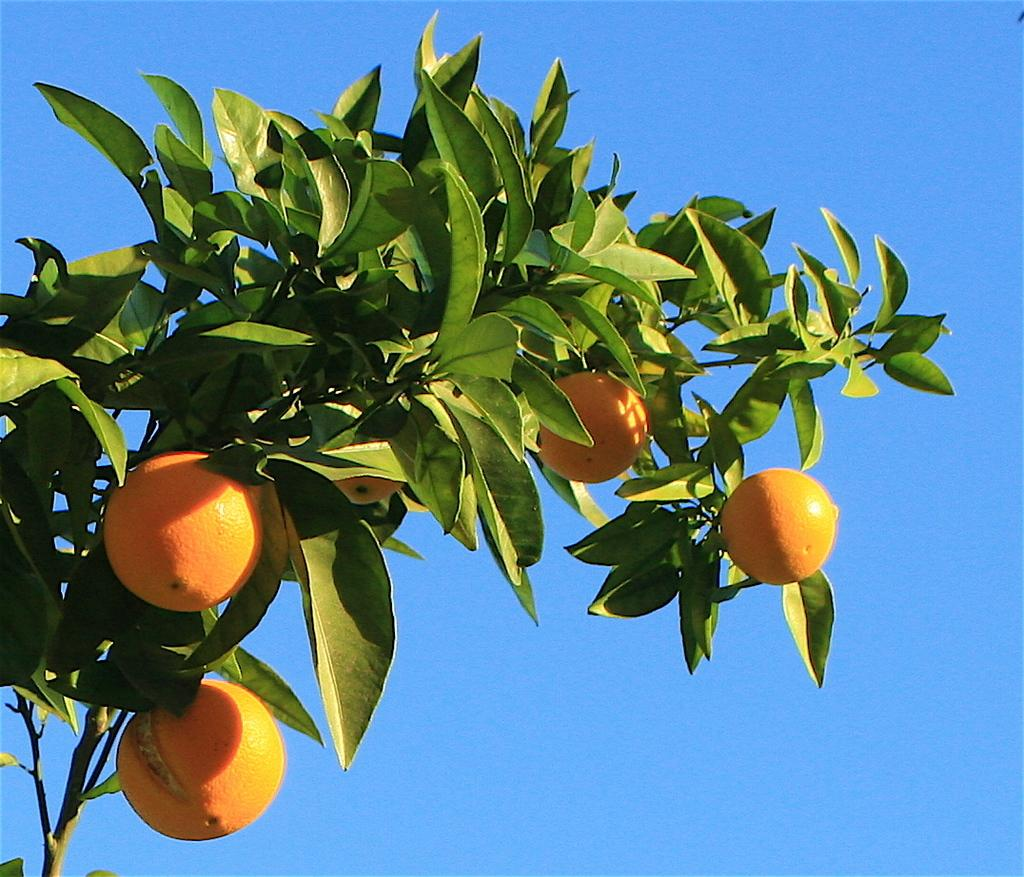What is the main object in the image? There is a tree in the image. What is the color of the tree? The tree is green in color. Are there any fruits on the tree? Yes, there are fruits on the tree. What colors are the fruits? The fruits are yellow and orange in color. What can be seen in the background of the image? The sky is visible in the background of the image. Is there a yoke attached to the tree in the image? No, there is no yoke present in the image. Can you tell me how many beds are visible in the image? There are no beds visible in the image; it features a tree with fruits and a sky background. 